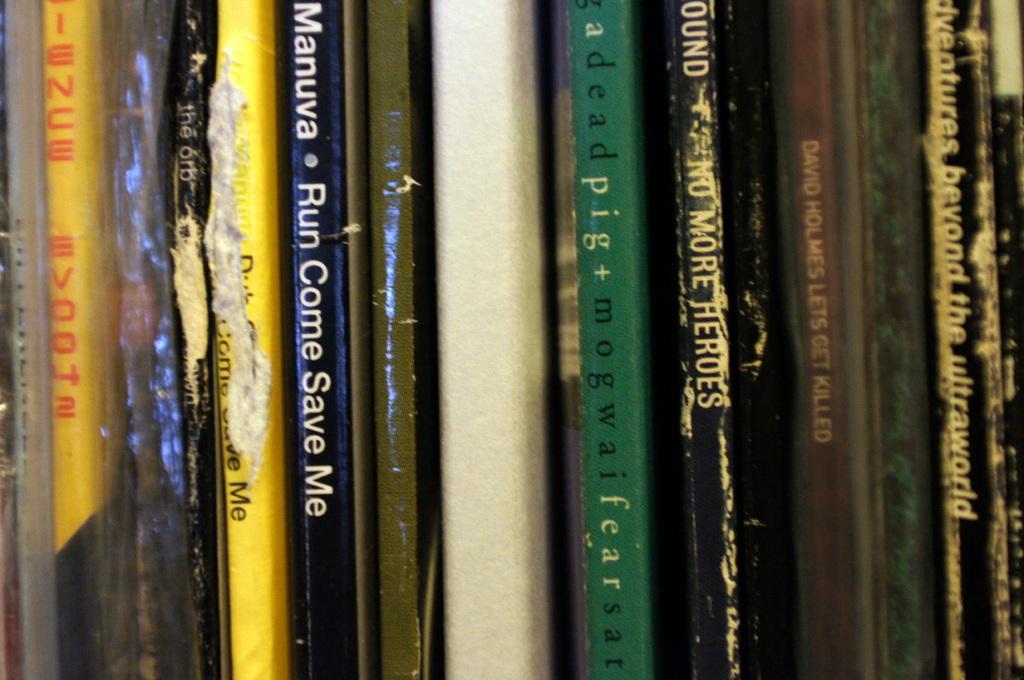What is the title of the book by manuva?
Give a very brief answer. Run come save me. What is the name of the book right of the green "pig" book?
Provide a succinct answer. No more heroes. 